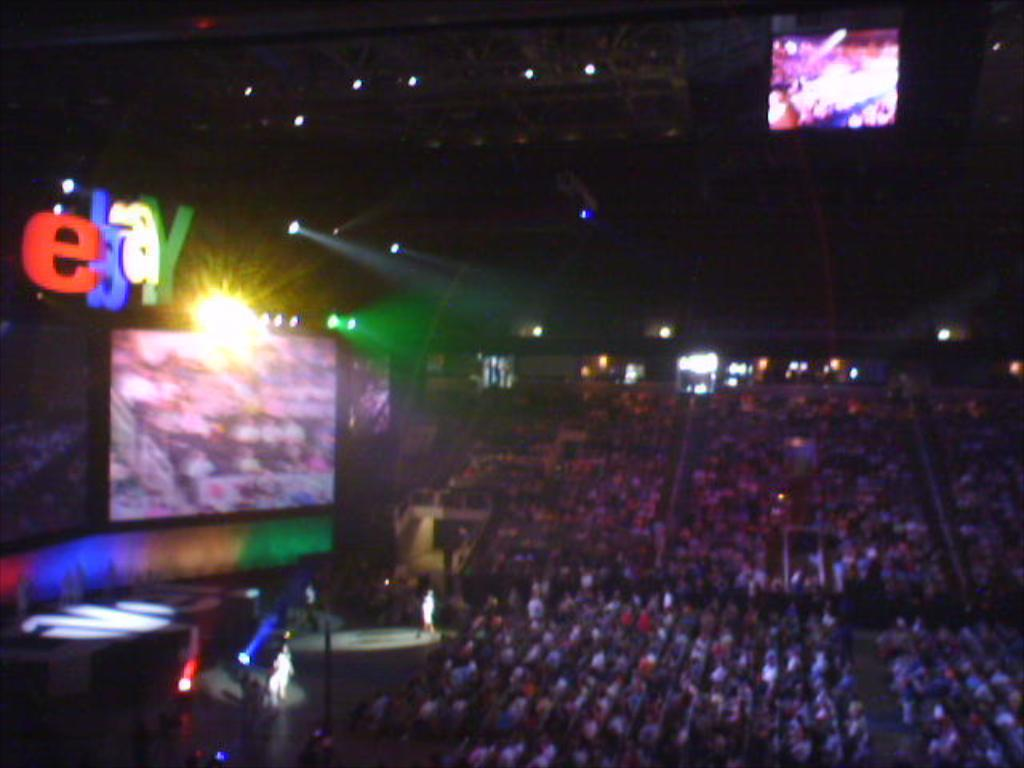<image>
Describe the image concisely. A packed indoor stadium has a sign above the stage that says ebay. 